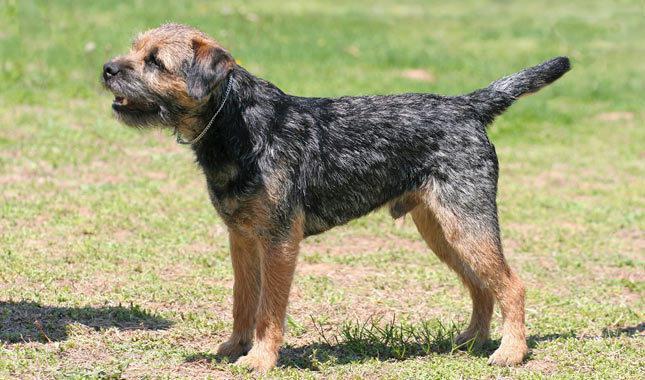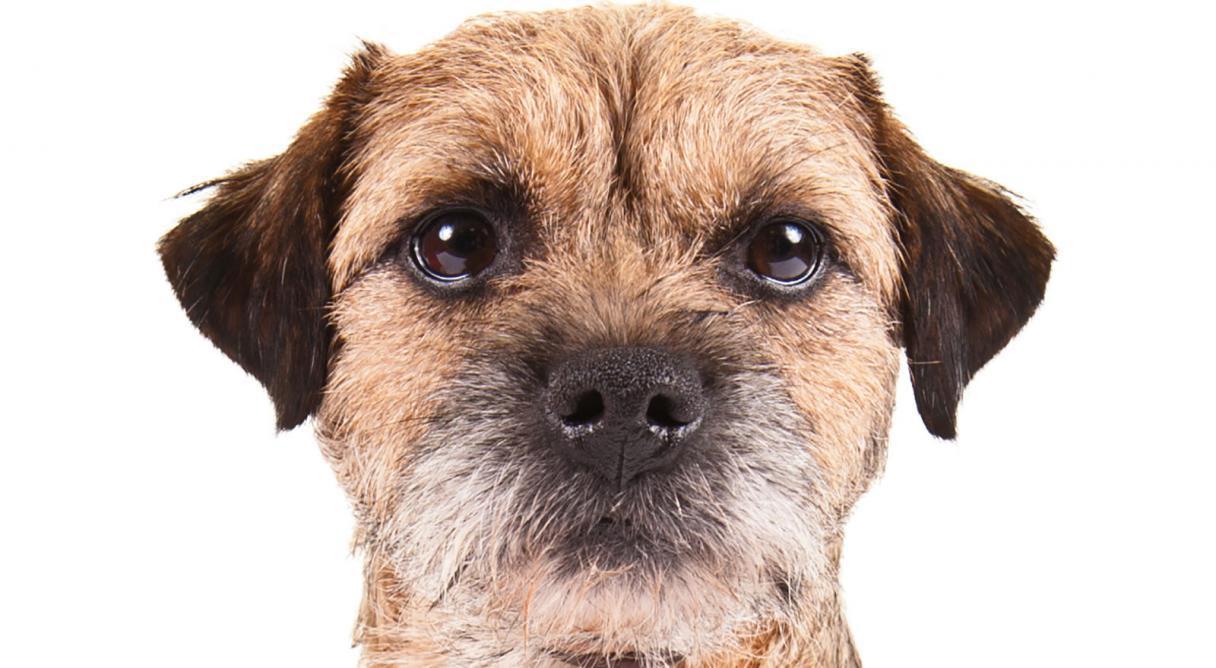The first image is the image on the left, the second image is the image on the right. Evaluate the accuracy of this statement regarding the images: "The dog on the left image is facing left while the dog on the right image is facing directly towards the camera.". Is it true? Answer yes or no. Yes. 